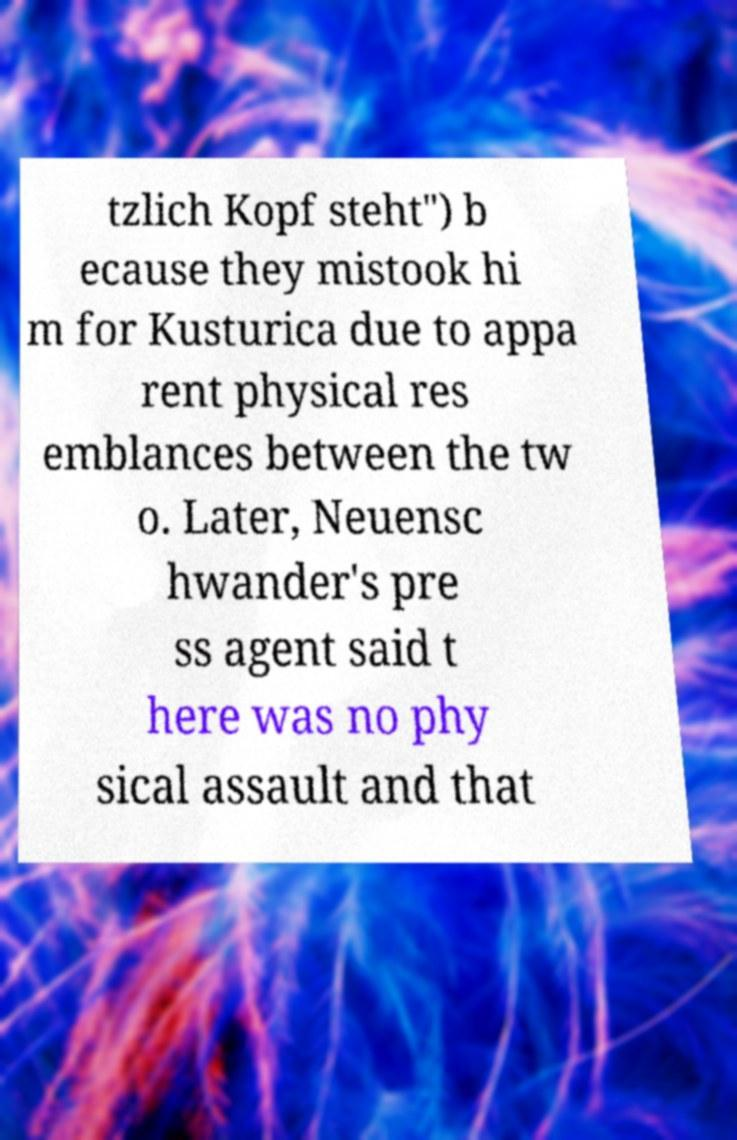There's text embedded in this image that I need extracted. Can you transcribe it verbatim? tzlich Kopf steht") b ecause they mistook hi m for Kusturica due to appa rent physical res emblances between the tw o. Later, Neuensc hwander's pre ss agent said t here was no phy sical assault and that 